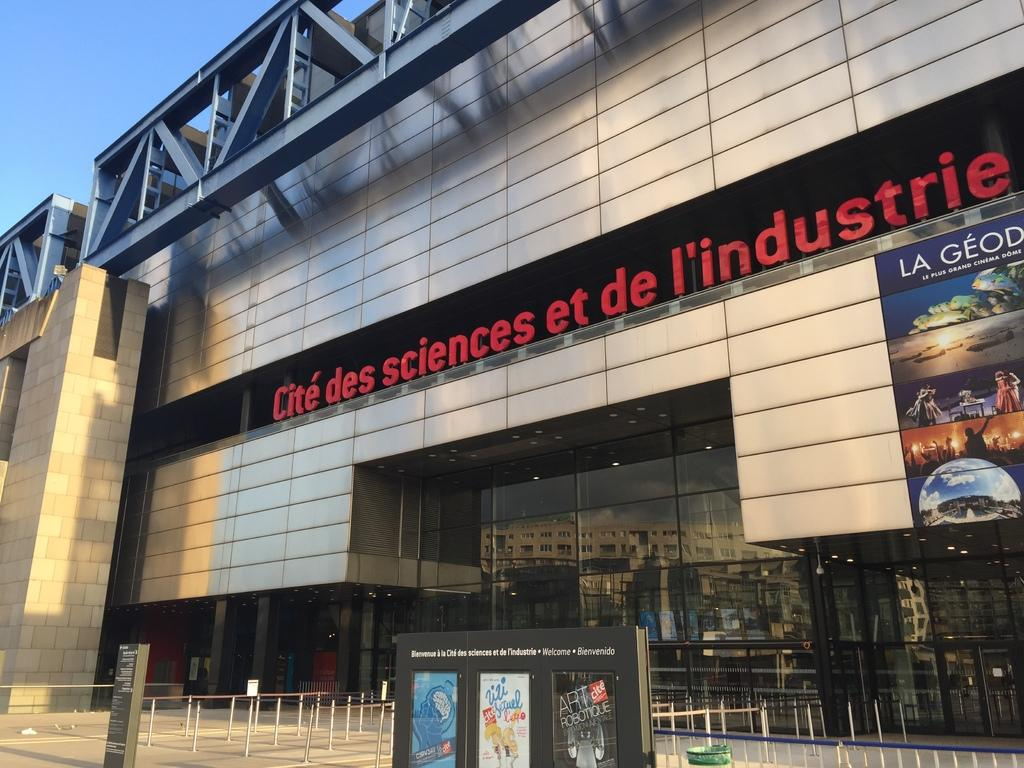<image>
Provide a brief description of the given image. The front of the Cite des Sciences et de L'industrie building. 